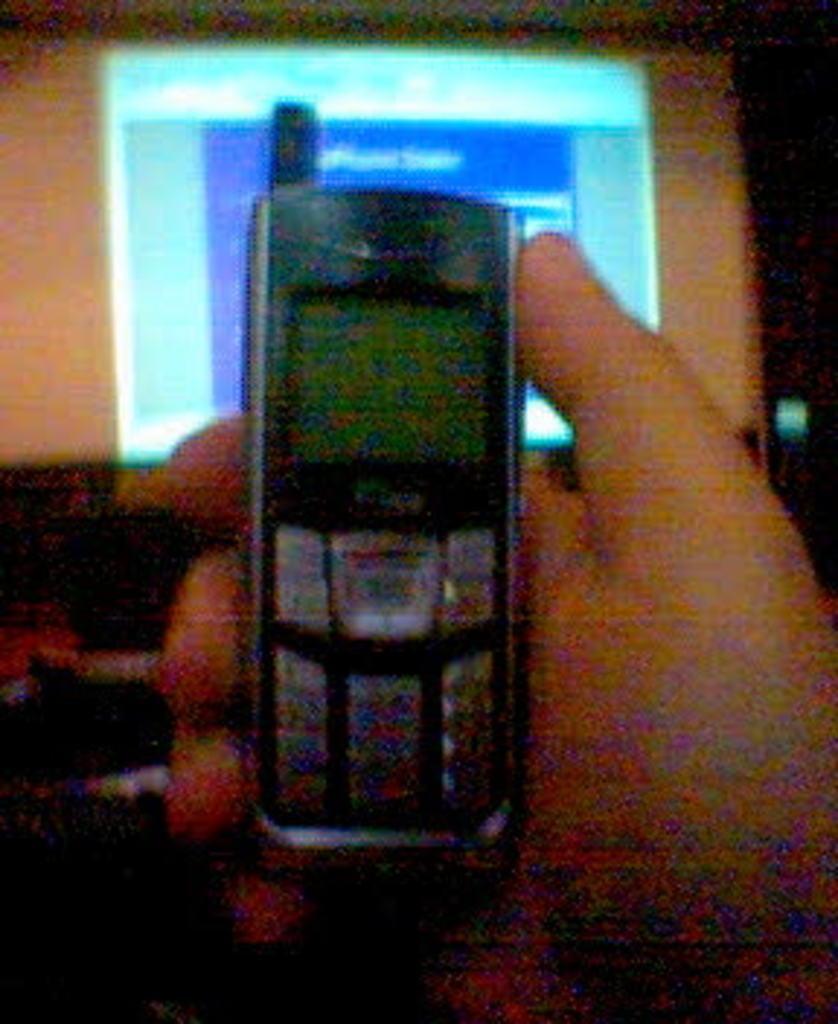In one or two sentences, can you explain what this image depicts? In this image I can see a person holding the mobile and in the background there is a screen or there is a monitor. 